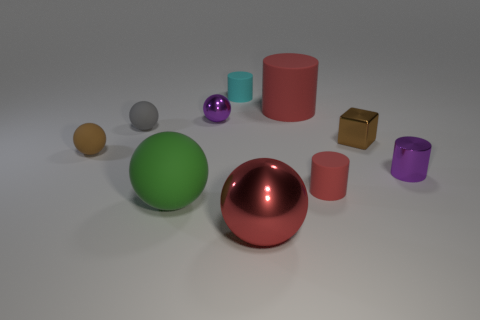Is there a tiny object of the same color as the large shiny thing?
Your response must be concise. Yes. Does the metallic sphere that is on the right side of the cyan rubber object have the same size as the small brown rubber ball?
Provide a succinct answer. No. Is the number of matte cylinders in front of the small gray ball the same as the number of cyan cylinders?
Provide a short and direct response. Yes. What number of things are either matte objects that are to the left of the green thing or tiny balls?
Ensure brevity in your answer.  3. What is the shape of the large thing that is both right of the large green thing and behind the large red metal thing?
Offer a very short reply. Cylinder. How many things are either tiny rubber cylinders that are behind the brown ball or red things that are on the right side of the red sphere?
Your answer should be very brief. 3. What number of other things are there of the same size as the cyan matte cylinder?
Provide a short and direct response. 6. There is a tiny ball that is in front of the small gray rubber object; is it the same color as the small shiny sphere?
Provide a short and direct response. No. What is the size of the cylinder that is on the left side of the small purple shiny cylinder and in front of the large red matte thing?
Your answer should be very brief. Small. What number of large objects are matte things or yellow blocks?
Offer a terse response. 2. 